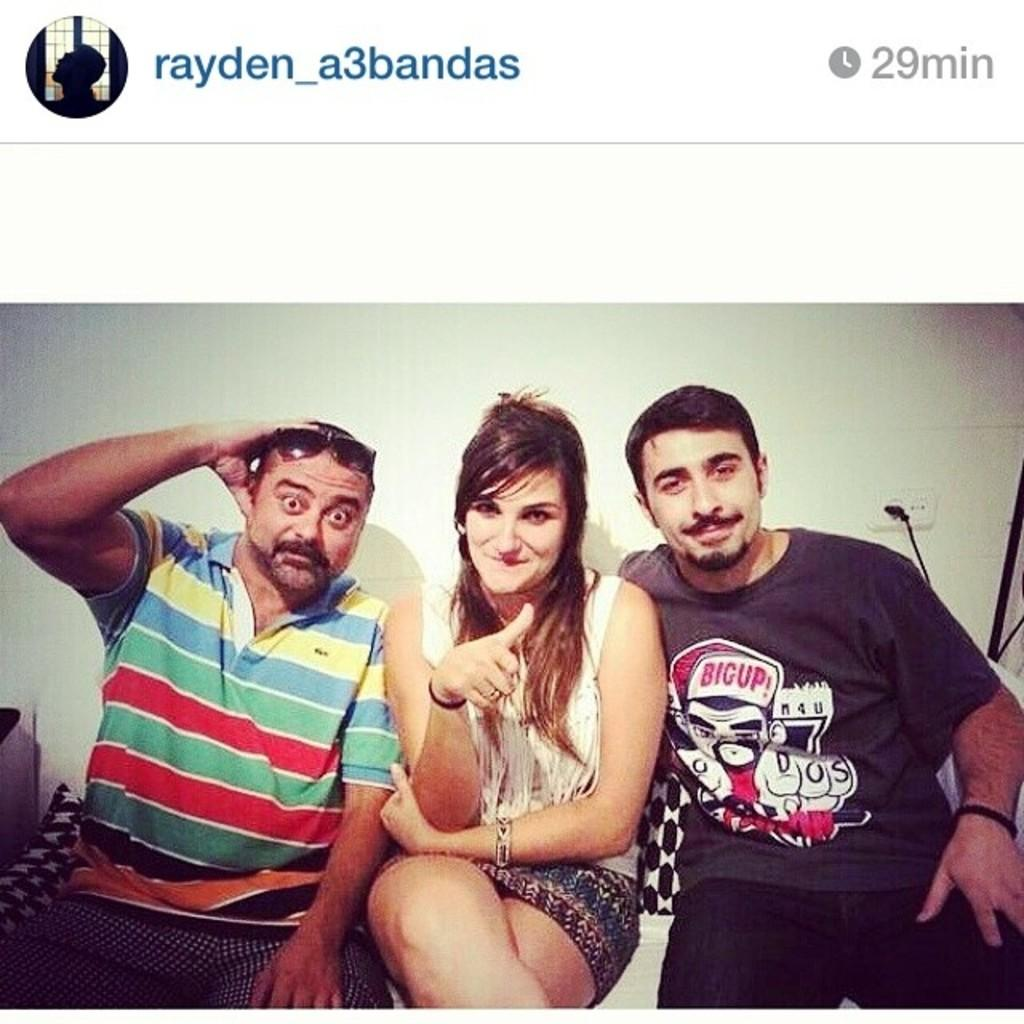What type of content is shown in the image? The image is a web page. Can you describe the people visible on the web page? There are people visible on the web page. What kind of background is depicted on the web page? There is a wall depicted on the web page. What else can be found on the web page besides people and the wall? There are objects present on the web page. Is there any written information on the web page? Yes, there is text on the web page. How does the stomach of the person on the web page feel? There is no information about the person's stomach or feelings in the image. 